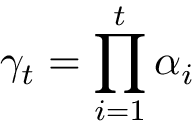Convert formula to latex. <formula><loc_0><loc_0><loc_500><loc_500>\gamma _ { t } = \prod _ { i = 1 } ^ { t } \alpha _ { i }</formula> 